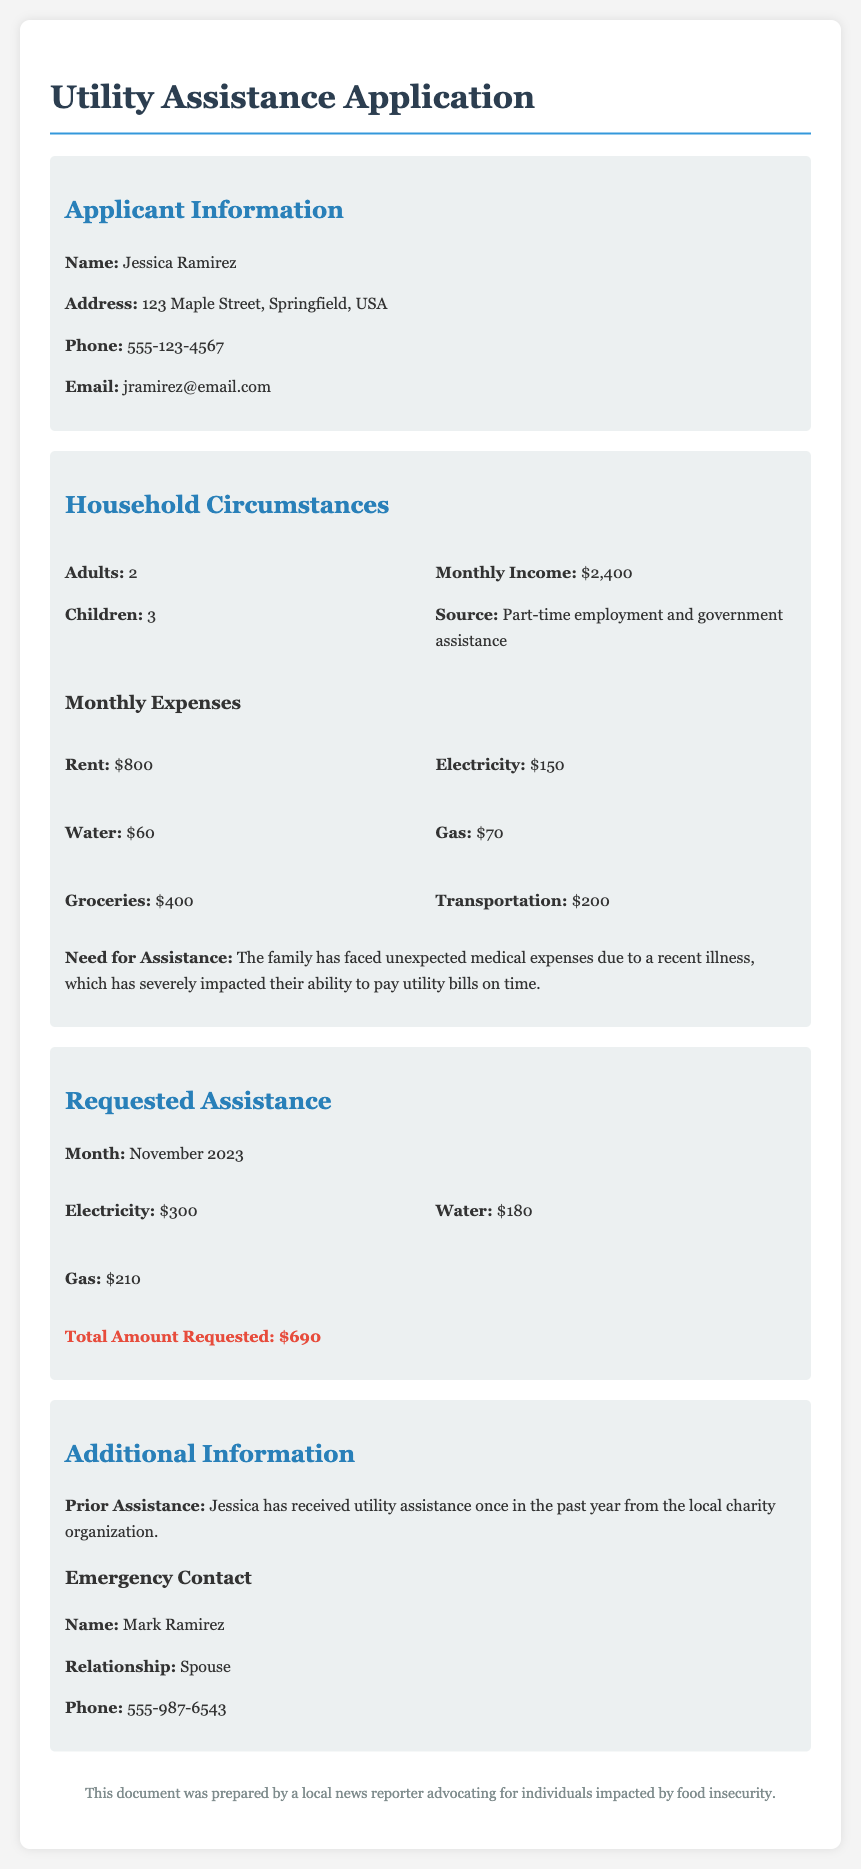What is the applicant's name? The applicant's name is listed in the document as Jessica Ramirez.
Answer: Jessica Ramirez How many children are in the household? The document states that there are 3 children living in the household.
Answer: 3 What is the total amount requested for utility assistance? The total amount requested for utility assistance is explicitly stated in the document as $690.
Answer: $690 What is the source of monthly income for the family? The document mentions that the source of income is part-time employment and government assistance.
Answer: Part-time employment and government assistance How much is the electricity expense for November 2023? The specific expense for electricity is detailed in the document as $300.
Answer: $300 How did unexpected medical expenses impact the family? The document explains that these expenses have severely impacted their ability to pay utility bills on time.
Answer: Severely impacted their ability to pay utility bills on time What was the amount of rent for the household? The amount for rent is stated as $800 in the monthly expenses section of the document.
Answer: $800 Who is listed as the emergency contact? The emergency contact's name is provided in the document as Mark Ramirez.
Answer: Mark Ramirez What relationship does the emergency contact have to Jessica Ramirez? The document specifies that Mark Ramirez is listed as her spouse.
Answer: Spouse 